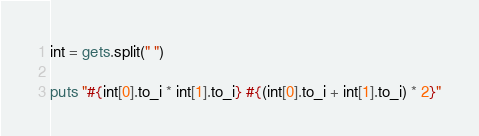<code> <loc_0><loc_0><loc_500><loc_500><_Ruby_>int = gets.split(" ")

puts "#{int[0].to_i * int[1].to_i} #{(int[0].to_i + int[1].to_i) * 2}"
</code> 